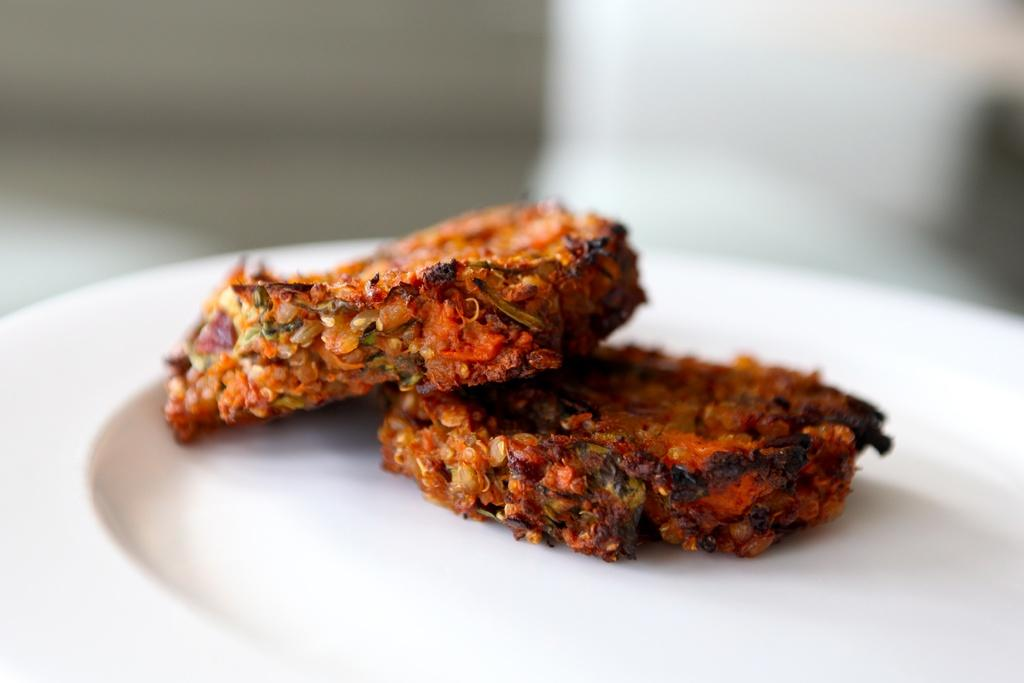What type of food can be seen in the image? There is cooked food in the image. How is the cooked food presented? The cooked food is placed on a white plate. Can you see a bee buzzing around the cooked food in the image? No, there is no bee present in the image. What type of material is the yoke made of in the image? There is no yoke present in the image. 